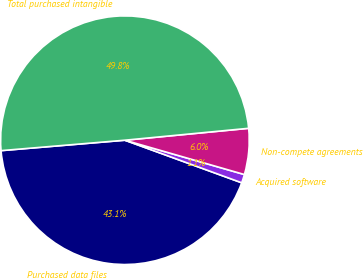<chart> <loc_0><loc_0><loc_500><loc_500><pie_chart><fcel>Purchased data files<fcel>Acquired software<fcel>Non-compete agreements<fcel>Total purchased intangible<nl><fcel>43.1%<fcel>1.11%<fcel>5.98%<fcel>49.81%<nl></chart> 